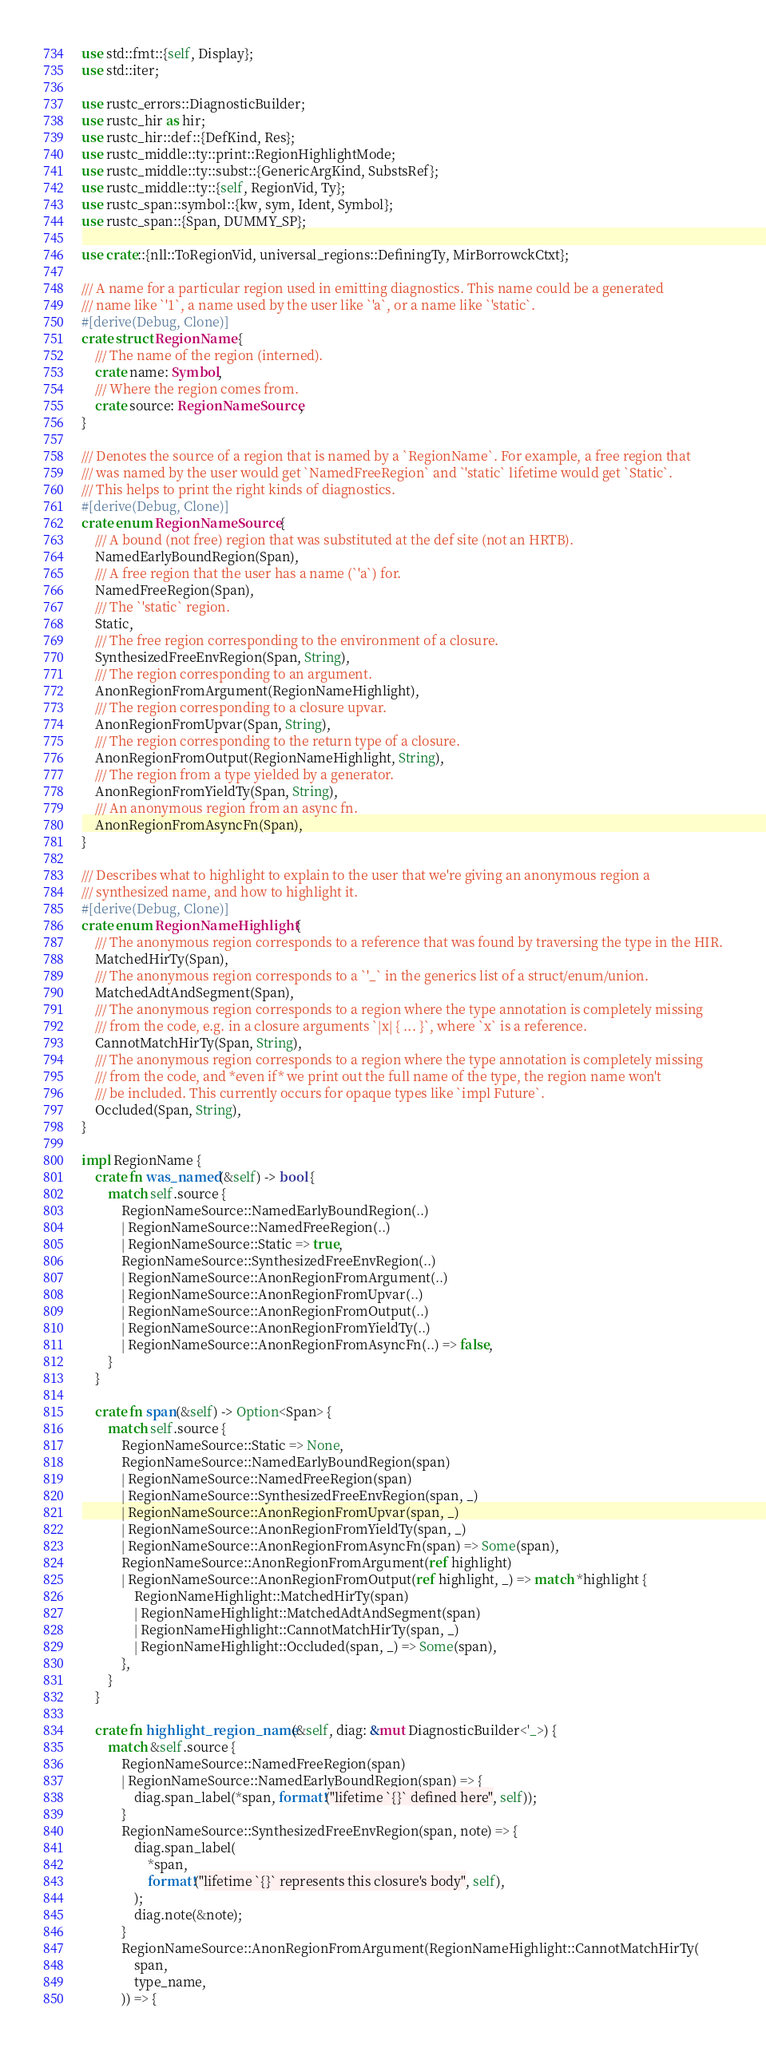Convert code to text. <code><loc_0><loc_0><loc_500><loc_500><_Rust_>use std::fmt::{self, Display};
use std::iter;

use rustc_errors::DiagnosticBuilder;
use rustc_hir as hir;
use rustc_hir::def::{DefKind, Res};
use rustc_middle::ty::print::RegionHighlightMode;
use rustc_middle::ty::subst::{GenericArgKind, SubstsRef};
use rustc_middle::ty::{self, RegionVid, Ty};
use rustc_span::symbol::{kw, sym, Ident, Symbol};
use rustc_span::{Span, DUMMY_SP};

use crate::{nll::ToRegionVid, universal_regions::DefiningTy, MirBorrowckCtxt};

/// A name for a particular region used in emitting diagnostics. This name could be a generated
/// name like `'1`, a name used by the user like `'a`, or a name like `'static`.
#[derive(Debug, Clone)]
crate struct RegionName {
    /// The name of the region (interned).
    crate name: Symbol,
    /// Where the region comes from.
    crate source: RegionNameSource,
}

/// Denotes the source of a region that is named by a `RegionName`. For example, a free region that
/// was named by the user would get `NamedFreeRegion` and `'static` lifetime would get `Static`.
/// This helps to print the right kinds of diagnostics.
#[derive(Debug, Clone)]
crate enum RegionNameSource {
    /// A bound (not free) region that was substituted at the def site (not an HRTB).
    NamedEarlyBoundRegion(Span),
    /// A free region that the user has a name (`'a`) for.
    NamedFreeRegion(Span),
    /// The `'static` region.
    Static,
    /// The free region corresponding to the environment of a closure.
    SynthesizedFreeEnvRegion(Span, String),
    /// The region corresponding to an argument.
    AnonRegionFromArgument(RegionNameHighlight),
    /// The region corresponding to a closure upvar.
    AnonRegionFromUpvar(Span, String),
    /// The region corresponding to the return type of a closure.
    AnonRegionFromOutput(RegionNameHighlight, String),
    /// The region from a type yielded by a generator.
    AnonRegionFromYieldTy(Span, String),
    /// An anonymous region from an async fn.
    AnonRegionFromAsyncFn(Span),
}

/// Describes what to highlight to explain to the user that we're giving an anonymous region a
/// synthesized name, and how to highlight it.
#[derive(Debug, Clone)]
crate enum RegionNameHighlight {
    /// The anonymous region corresponds to a reference that was found by traversing the type in the HIR.
    MatchedHirTy(Span),
    /// The anonymous region corresponds to a `'_` in the generics list of a struct/enum/union.
    MatchedAdtAndSegment(Span),
    /// The anonymous region corresponds to a region where the type annotation is completely missing
    /// from the code, e.g. in a closure arguments `|x| { ... }`, where `x` is a reference.
    CannotMatchHirTy(Span, String),
    /// The anonymous region corresponds to a region where the type annotation is completely missing
    /// from the code, and *even if* we print out the full name of the type, the region name won't
    /// be included. This currently occurs for opaque types like `impl Future`.
    Occluded(Span, String),
}

impl RegionName {
    crate fn was_named(&self) -> bool {
        match self.source {
            RegionNameSource::NamedEarlyBoundRegion(..)
            | RegionNameSource::NamedFreeRegion(..)
            | RegionNameSource::Static => true,
            RegionNameSource::SynthesizedFreeEnvRegion(..)
            | RegionNameSource::AnonRegionFromArgument(..)
            | RegionNameSource::AnonRegionFromUpvar(..)
            | RegionNameSource::AnonRegionFromOutput(..)
            | RegionNameSource::AnonRegionFromYieldTy(..)
            | RegionNameSource::AnonRegionFromAsyncFn(..) => false,
        }
    }

    crate fn span(&self) -> Option<Span> {
        match self.source {
            RegionNameSource::Static => None,
            RegionNameSource::NamedEarlyBoundRegion(span)
            | RegionNameSource::NamedFreeRegion(span)
            | RegionNameSource::SynthesizedFreeEnvRegion(span, _)
            | RegionNameSource::AnonRegionFromUpvar(span, _)
            | RegionNameSource::AnonRegionFromYieldTy(span, _)
            | RegionNameSource::AnonRegionFromAsyncFn(span) => Some(span),
            RegionNameSource::AnonRegionFromArgument(ref highlight)
            | RegionNameSource::AnonRegionFromOutput(ref highlight, _) => match *highlight {
                RegionNameHighlight::MatchedHirTy(span)
                | RegionNameHighlight::MatchedAdtAndSegment(span)
                | RegionNameHighlight::CannotMatchHirTy(span, _)
                | RegionNameHighlight::Occluded(span, _) => Some(span),
            },
        }
    }

    crate fn highlight_region_name(&self, diag: &mut DiagnosticBuilder<'_>) {
        match &self.source {
            RegionNameSource::NamedFreeRegion(span)
            | RegionNameSource::NamedEarlyBoundRegion(span) => {
                diag.span_label(*span, format!("lifetime `{}` defined here", self));
            }
            RegionNameSource::SynthesizedFreeEnvRegion(span, note) => {
                diag.span_label(
                    *span,
                    format!("lifetime `{}` represents this closure's body", self),
                );
                diag.note(&note);
            }
            RegionNameSource::AnonRegionFromArgument(RegionNameHighlight::CannotMatchHirTy(
                span,
                type_name,
            )) => {</code> 